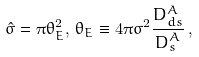Convert formula to latex. <formula><loc_0><loc_0><loc_500><loc_500>\hat { \sigma } = \pi \theta ^ { 2 } _ { E } , \, \theta _ { E } \equiv 4 \pi \sigma ^ { 2 } \frac { D ^ { A } _ { d s } } { D ^ { A } _ { s } } \, ,</formula> 